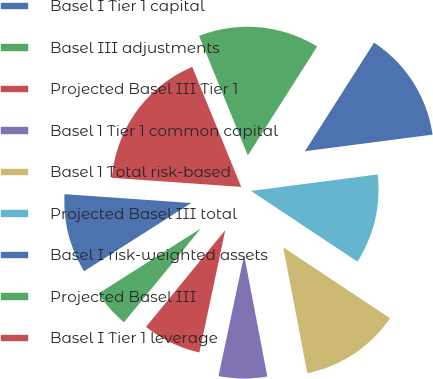<chart> <loc_0><loc_0><loc_500><loc_500><pie_chart><fcel>Basel I Tier 1 capital<fcel>Basel III adjustments<fcel>Projected Basel III Tier 1<fcel>Basel 1 Tier 1 common capital<fcel>Basel 1 Total risk-based<fcel>Projected Basel III total<fcel>Basel I risk-weighted assets<fcel>Projected Basel III<fcel>Basel I Tier 1 leverage<nl><fcel>10.13%<fcel>5.06%<fcel>7.6%<fcel>6.33%<fcel>12.66%<fcel>11.39%<fcel>13.92%<fcel>15.19%<fcel>17.72%<nl></chart> 